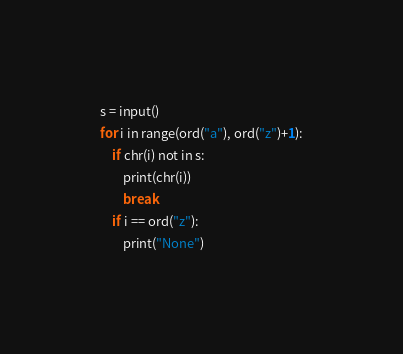Convert code to text. <code><loc_0><loc_0><loc_500><loc_500><_Python_>s = input()
for i in range(ord("a"), ord("z")+1):
    if chr(i) not in s:
        print(chr(i))
        break
    if i == ord("z"):
        print("None")</code> 